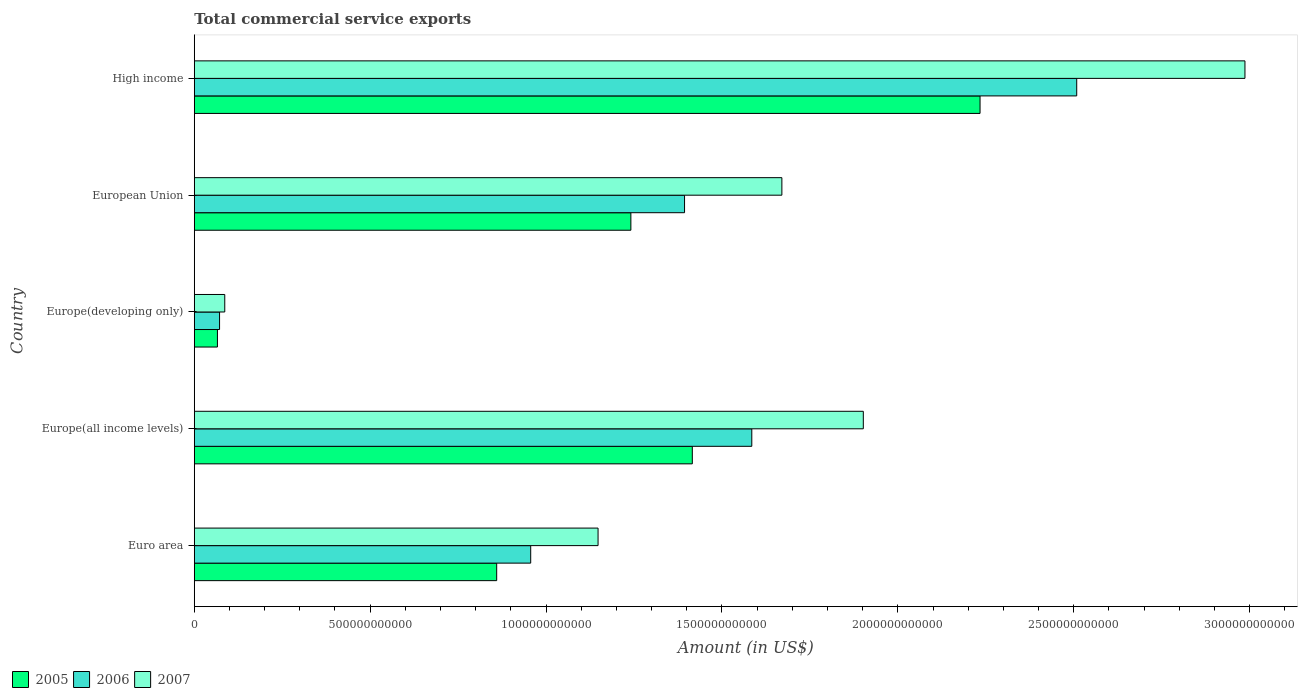How many different coloured bars are there?
Your response must be concise. 3. Are the number of bars per tick equal to the number of legend labels?
Ensure brevity in your answer.  Yes. What is the label of the 5th group of bars from the top?
Provide a short and direct response. Euro area. In how many cases, is the number of bars for a given country not equal to the number of legend labels?
Keep it short and to the point. 0. What is the total commercial service exports in 2005 in Europe(developing only)?
Provide a succinct answer. 6.59e+1. Across all countries, what is the maximum total commercial service exports in 2006?
Provide a succinct answer. 2.51e+12. Across all countries, what is the minimum total commercial service exports in 2006?
Offer a very short reply. 7.19e+1. In which country was the total commercial service exports in 2007 maximum?
Provide a succinct answer. High income. In which country was the total commercial service exports in 2007 minimum?
Keep it short and to the point. Europe(developing only). What is the total total commercial service exports in 2006 in the graph?
Provide a short and direct response. 6.52e+12. What is the difference between the total commercial service exports in 2006 in Europe(developing only) and that in High income?
Your answer should be compact. -2.44e+12. What is the difference between the total commercial service exports in 2007 in Europe(developing only) and the total commercial service exports in 2005 in European Union?
Offer a very short reply. -1.15e+12. What is the average total commercial service exports in 2007 per country?
Provide a short and direct response. 1.56e+12. What is the difference between the total commercial service exports in 2006 and total commercial service exports in 2005 in Euro area?
Give a very brief answer. 9.67e+1. What is the ratio of the total commercial service exports in 2006 in European Union to that in High income?
Offer a terse response. 0.56. Is the total commercial service exports in 2005 in Europe(developing only) less than that in European Union?
Your answer should be very brief. Yes. Is the difference between the total commercial service exports in 2006 in Euro area and European Union greater than the difference between the total commercial service exports in 2005 in Euro area and European Union?
Give a very brief answer. No. What is the difference between the highest and the second highest total commercial service exports in 2007?
Provide a succinct answer. 1.08e+12. What is the difference between the highest and the lowest total commercial service exports in 2006?
Your answer should be very brief. 2.44e+12. In how many countries, is the total commercial service exports in 2005 greater than the average total commercial service exports in 2005 taken over all countries?
Give a very brief answer. 3. What does the 1st bar from the top in High income represents?
Your response must be concise. 2007. What does the 1st bar from the bottom in European Union represents?
Ensure brevity in your answer.  2005. Is it the case that in every country, the sum of the total commercial service exports in 2007 and total commercial service exports in 2006 is greater than the total commercial service exports in 2005?
Your response must be concise. Yes. How many bars are there?
Provide a succinct answer. 15. Are all the bars in the graph horizontal?
Your response must be concise. Yes. How many countries are there in the graph?
Ensure brevity in your answer.  5. What is the difference between two consecutive major ticks on the X-axis?
Provide a succinct answer. 5.00e+11. How are the legend labels stacked?
Offer a terse response. Horizontal. What is the title of the graph?
Ensure brevity in your answer.  Total commercial service exports. What is the label or title of the Y-axis?
Offer a terse response. Country. What is the Amount (in US$) of 2005 in Euro area?
Give a very brief answer. 8.60e+11. What is the Amount (in US$) of 2006 in Euro area?
Your response must be concise. 9.56e+11. What is the Amount (in US$) of 2007 in Euro area?
Offer a terse response. 1.15e+12. What is the Amount (in US$) in 2005 in Europe(all income levels)?
Give a very brief answer. 1.42e+12. What is the Amount (in US$) in 2006 in Europe(all income levels)?
Give a very brief answer. 1.58e+12. What is the Amount (in US$) in 2007 in Europe(all income levels)?
Your answer should be very brief. 1.90e+12. What is the Amount (in US$) of 2005 in Europe(developing only)?
Your answer should be compact. 6.59e+1. What is the Amount (in US$) of 2006 in Europe(developing only)?
Make the answer very short. 7.19e+1. What is the Amount (in US$) of 2007 in Europe(developing only)?
Give a very brief answer. 8.67e+1. What is the Amount (in US$) of 2005 in European Union?
Your answer should be compact. 1.24e+12. What is the Amount (in US$) of 2006 in European Union?
Give a very brief answer. 1.39e+12. What is the Amount (in US$) of 2007 in European Union?
Provide a succinct answer. 1.67e+12. What is the Amount (in US$) in 2005 in High income?
Keep it short and to the point. 2.23e+12. What is the Amount (in US$) in 2006 in High income?
Your response must be concise. 2.51e+12. What is the Amount (in US$) in 2007 in High income?
Offer a terse response. 2.99e+12. Across all countries, what is the maximum Amount (in US$) in 2005?
Make the answer very short. 2.23e+12. Across all countries, what is the maximum Amount (in US$) of 2006?
Offer a very short reply. 2.51e+12. Across all countries, what is the maximum Amount (in US$) in 2007?
Offer a terse response. 2.99e+12. Across all countries, what is the minimum Amount (in US$) in 2005?
Provide a short and direct response. 6.59e+1. Across all countries, what is the minimum Amount (in US$) in 2006?
Give a very brief answer. 7.19e+1. Across all countries, what is the minimum Amount (in US$) in 2007?
Give a very brief answer. 8.67e+1. What is the total Amount (in US$) of 2005 in the graph?
Offer a terse response. 5.82e+12. What is the total Amount (in US$) in 2006 in the graph?
Give a very brief answer. 6.52e+12. What is the total Amount (in US$) of 2007 in the graph?
Make the answer very short. 7.79e+12. What is the difference between the Amount (in US$) in 2005 in Euro area and that in Europe(all income levels)?
Your answer should be compact. -5.56e+11. What is the difference between the Amount (in US$) of 2006 in Euro area and that in Europe(all income levels)?
Make the answer very short. -6.29e+11. What is the difference between the Amount (in US$) of 2007 in Euro area and that in Europe(all income levels)?
Provide a short and direct response. -7.54e+11. What is the difference between the Amount (in US$) in 2005 in Euro area and that in Europe(developing only)?
Ensure brevity in your answer.  7.94e+11. What is the difference between the Amount (in US$) in 2006 in Euro area and that in Europe(developing only)?
Make the answer very short. 8.84e+11. What is the difference between the Amount (in US$) in 2007 in Euro area and that in Europe(developing only)?
Your answer should be very brief. 1.06e+12. What is the difference between the Amount (in US$) of 2005 in Euro area and that in European Union?
Provide a succinct answer. -3.81e+11. What is the difference between the Amount (in US$) in 2006 in Euro area and that in European Union?
Ensure brevity in your answer.  -4.37e+11. What is the difference between the Amount (in US$) of 2007 in Euro area and that in European Union?
Provide a short and direct response. -5.23e+11. What is the difference between the Amount (in US$) in 2005 in Euro area and that in High income?
Ensure brevity in your answer.  -1.37e+12. What is the difference between the Amount (in US$) in 2006 in Euro area and that in High income?
Your answer should be compact. -1.55e+12. What is the difference between the Amount (in US$) in 2007 in Euro area and that in High income?
Your answer should be compact. -1.84e+12. What is the difference between the Amount (in US$) in 2005 in Europe(all income levels) and that in Europe(developing only)?
Make the answer very short. 1.35e+12. What is the difference between the Amount (in US$) of 2006 in Europe(all income levels) and that in Europe(developing only)?
Offer a very short reply. 1.51e+12. What is the difference between the Amount (in US$) of 2007 in Europe(all income levels) and that in Europe(developing only)?
Give a very brief answer. 1.82e+12. What is the difference between the Amount (in US$) in 2005 in Europe(all income levels) and that in European Union?
Provide a succinct answer. 1.75e+11. What is the difference between the Amount (in US$) of 2006 in Europe(all income levels) and that in European Union?
Provide a succinct answer. 1.91e+11. What is the difference between the Amount (in US$) of 2007 in Europe(all income levels) and that in European Union?
Offer a terse response. 2.32e+11. What is the difference between the Amount (in US$) of 2005 in Europe(all income levels) and that in High income?
Provide a short and direct response. -8.18e+11. What is the difference between the Amount (in US$) in 2006 in Europe(all income levels) and that in High income?
Your answer should be very brief. -9.24e+11. What is the difference between the Amount (in US$) in 2007 in Europe(all income levels) and that in High income?
Provide a short and direct response. -1.08e+12. What is the difference between the Amount (in US$) in 2005 in Europe(developing only) and that in European Union?
Your response must be concise. -1.18e+12. What is the difference between the Amount (in US$) in 2006 in Europe(developing only) and that in European Union?
Your answer should be compact. -1.32e+12. What is the difference between the Amount (in US$) in 2007 in Europe(developing only) and that in European Union?
Make the answer very short. -1.58e+12. What is the difference between the Amount (in US$) in 2005 in Europe(developing only) and that in High income?
Your answer should be very brief. -2.17e+12. What is the difference between the Amount (in US$) in 2006 in Europe(developing only) and that in High income?
Offer a very short reply. -2.44e+12. What is the difference between the Amount (in US$) in 2007 in Europe(developing only) and that in High income?
Provide a succinct answer. -2.90e+12. What is the difference between the Amount (in US$) in 2005 in European Union and that in High income?
Offer a very short reply. -9.93e+11. What is the difference between the Amount (in US$) of 2006 in European Union and that in High income?
Offer a very short reply. -1.11e+12. What is the difference between the Amount (in US$) in 2007 in European Union and that in High income?
Your answer should be compact. -1.32e+12. What is the difference between the Amount (in US$) of 2005 in Euro area and the Amount (in US$) of 2006 in Europe(all income levels)?
Your answer should be very brief. -7.25e+11. What is the difference between the Amount (in US$) of 2005 in Euro area and the Amount (in US$) of 2007 in Europe(all income levels)?
Your response must be concise. -1.04e+12. What is the difference between the Amount (in US$) in 2006 in Euro area and the Amount (in US$) in 2007 in Europe(all income levels)?
Keep it short and to the point. -9.46e+11. What is the difference between the Amount (in US$) of 2005 in Euro area and the Amount (in US$) of 2006 in Europe(developing only)?
Provide a short and direct response. 7.88e+11. What is the difference between the Amount (in US$) in 2005 in Euro area and the Amount (in US$) in 2007 in Europe(developing only)?
Your answer should be compact. 7.73e+11. What is the difference between the Amount (in US$) in 2006 in Euro area and the Amount (in US$) in 2007 in Europe(developing only)?
Ensure brevity in your answer.  8.70e+11. What is the difference between the Amount (in US$) of 2005 in Euro area and the Amount (in US$) of 2006 in European Union?
Provide a succinct answer. -5.34e+11. What is the difference between the Amount (in US$) of 2005 in Euro area and the Amount (in US$) of 2007 in European Union?
Provide a succinct answer. -8.11e+11. What is the difference between the Amount (in US$) in 2006 in Euro area and the Amount (in US$) in 2007 in European Union?
Provide a short and direct response. -7.14e+11. What is the difference between the Amount (in US$) of 2005 in Euro area and the Amount (in US$) of 2006 in High income?
Give a very brief answer. -1.65e+12. What is the difference between the Amount (in US$) of 2005 in Euro area and the Amount (in US$) of 2007 in High income?
Keep it short and to the point. -2.13e+12. What is the difference between the Amount (in US$) of 2006 in Euro area and the Amount (in US$) of 2007 in High income?
Give a very brief answer. -2.03e+12. What is the difference between the Amount (in US$) of 2005 in Europe(all income levels) and the Amount (in US$) of 2006 in Europe(developing only)?
Offer a very short reply. 1.34e+12. What is the difference between the Amount (in US$) in 2005 in Europe(all income levels) and the Amount (in US$) in 2007 in Europe(developing only)?
Your answer should be very brief. 1.33e+12. What is the difference between the Amount (in US$) of 2006 in Europe(all income levels) and the Amount (in US$) of 2007 in Europe(developing only)?
Keep it short and to the point. 1.50e+12. What is the difference between the Amount (in US$) of 2005 in Europe(all income levels) and the Amount (in US$) of 2006 in European Union?
Give a very brief answer. 2.21e+1. What is the difference between the Amount (in US$) in 2005 in Europe(all income levels) and the Amount (in US$) in 2007 in European Union?
Your response must be concise. -2.55e+11. What is the difference between the Amount (in US$) in 2006 in Europe(all income levels) and the Amount (in US$) in 2007 in European Union?
Make the answer very short. -8.55e+1. What is the difference between the Amount (in US$) in 2005 in Europe(all income levels) and the Amount (in US$) in 2006 in High income?
Keep it short and to the point. -1.09e+12. What is the difference between the Amount (in US$) of 2005 in Europe(all income levels) and the Amount (in US$) of 2007 in High income?
Ensure brevity in your answer.  -1.57e+12. What is the difference between the Amount (in US$) in 2006 in Europe(all income levels) and the Amount (in US$) in 2007 in High income?
Make the answer very short. -1.40e+12. What is the difference between the Amount (in US$) in 2005 in Europe(developing only) and the Amount (in US$) in 2006 in European Union?
Your response must be concise. -1.33e+12. What is the difference between the Amount (in US$) in 2005 in Europe(developing only) and the Amount (in US$) in 2007 in European Union?
Offer a terse response. -1.60e+12. What is the difference between the Amount (in US$) of 2006 in Europe(developing only) and the Amount (in US$) of 2007 in European Union?
Offer a very short reply. -1.60e+12. What is the difference between the Amount (in US$) of 2005 in Europe(developing only) and the Amount (in US$) of 2006 in High income?
Your answer should be compact. -2.44e+12. What is the difference between the Amount (in US$) in 2005 in Europe(developing only) and the Amount (in US$) in 2007 in High income?
Your answer should be compact. -2.92e+12. What is the difference between the Amount (in US$) in 2006 in Europe(developing only) and the Amount (in US$) in 2007 in High income?
Offer a terse response. -2.91e+12. What is the difference between the Amount (in US$) of 2005 in European Union and the Amount (in US$) of 2006 in High income?
Ensure brevity in your answer.  -1.27e+12. What is the difference between the Amount (in US$) of 2005 in European Union and the Amount (in US$) of 2007 in High income?
Provide a short and direct response. -1.75e+12. What is the difference between the Amount (in US$) in 2006 in European Union and the Amount (in US$) in 2007 in High income?
Give a very brief answer. -1.59e+12. What is the average Amount (in US$) of 2005 per country?
Offer a terse response. 1.16e+12. What is the average Amount (in US$) in 2006 per country?
Your response must be concise. 1.30e+12. What is the average Amount (in US$) in 2007 per country?
Give a very brief answer. 1.56e+12. What is the difference between the Amount (in US$) of 2005 and Amount (in US$) of 2006 in Euro area?
Your answer should be compact. -9.67e+1. What is the difference between the Amount (in US$) of 2005 and Amount (in US$) of 2007 in Euro area?
Ensure brevity in your answer.  -2.88e+11. What is the difference between the Amount (in US$) of 2006 and Amount (in US$) of 2007 in Euro area?
Your answer should be very brief. -1.91e+11. What is the difference between the Amount (in US$) of 2005 and Amount (in US$) of 2006 in Europe(all income levels)?
Offer a very short reply. -1.69e+11. What is the difference between the Amount (in US$) in 2005 and Amount (in US$) in 2007 in Europe(all income levels)?
Provide a short and direct response. -4.86e+11. What is the difference between the Amount (in US$) of 2006 and Amount (in US$) of 2007 in Europe(all income levels)?
Give a very brief answer. -3.17e+11. What is the difference between the Amount (in US$) in 2005 and Amount (in US$) in 2006 in Europe(developing only)?
Provide a succinct answer. -6.08e+09. What is the difference between the Amount (in US$) in 2005 and Amount (in US$) in 2007 in Europe(developing only)?
Your answer should be compact. -2.09e+1. What is the difference between the Amount (in US$) of 2006 and Amount (in US$) of 2007 in Europe(developing only)?
Your answer should be compact. -1.48e+1. What is the difference between the Amount (in US$) in 2005 and Amount (in US$) in 2006 in European Union?
Provide a succinct answer. -1.53e+11. What is the difference between the Amount (in US$) in 2005 and Amount (in US$) in 2007 in European Union?
Provide a short and direct response. -4.29e+11. What is the difference between the Amount (in US$) in 2006 and Amount (in US$) in 2007 in European Union?
Your answer should be very brief. -2.77e+11. What is the difference between the Amount (in US$) in 2005 and Amount (in US$) in 2006 in High income?
Give a very brief answer. -2.75e+11. What is the difference between the Amount (in US$) of 2005 and Amount (in US$) of 2007 in High income?
Make the answer very short. -7.53e+11. What is the difference between the Amount (in US$) in 2006 and Amount (in US$) in 2007 in High income?
Your answer should be compact. -4.78e+11. What is the ratio of the Amount (in US$) in 2005 in Euro area to that in Europe(all income levels)?
Your response must be concise. 0.61. What is the ratio of the Amount (in US$) of 2006 in Euro area to that in Europe(all income levels)?
Make the answer very short. 0.6. What is the ratio of the Amount (in US$) in 2007 in Euro area to that in Europe(all income levels)?
Provide a succinct answer. 0.6. What is the ratio of the Amount (in US$) in 2005 in Euro area to that in Europe(developing only)?
Offer a very short reply. 13.06. What is the ratio of the Amount (in US$) of 2006 in Euro area to that in Europe(developing only)?
Ensure brevity in your answer.  13.3. What is the ratio of the Amount (in US$) in 2007 in Euro area to that in Europe(developing only)?
Your answer should be very brief. 13.24. What is the ratio of the Amount (in US$) in 2005 in Euro area to that in European Union?
Your answer should be very brief. 0.69. What is the ratio of the Amount (in US$) in 2006 in Euro area to that in European Union?
Offer a terse response. 0.69. What is the ratio of the Amount (in US$) in 2007 in Euro area to that in European Union?
Keep it short and to the point. 0.69. What is the ratio of the Amount (in US$) of 2005 in Euro area to that in High income?
Offer a very short reply. 0.38. What is the ratio of the Amount (in US$) of 2006 in Euro area to that in High income?
Ensure brevity in your answer.  0.38. What is the ratio of the Amount (in US$) of 2007 in Euro area to that in High income?
Keep it short and to the point. 0.38. What is the ratio of the Amount (in US$) of 2005 in Europe(all income levels) to that in Europe(developing only)?
Keep it short and to the point. 21.5. What is the ratio of the Amount (in US$) in 2006 in Europe(all income levels) to that in Europe(developing only)?
Your answer should be compact. 22.03. What is the ratio of the Amount (in US$) in 2007 in Europe(all income levels) to that in Europe(developing only)?
Your answer should be very brief. 21.93. What is the ratio of the Amount (in US$) in 2005 in Europe(all income levels) to that in European Union?
Offer a terse response. 1.14. What is the ratio of the Amount (in US$) of 2006 in Europe(all income levels) to that in European Union?
Ensure brevity in your answer.  1.14. What is the ratio of the Amount (in US$) of 2007 in Europe(all income levels) to that in European Union?
Provide a short and direct response. 1.14. What is the ratio of the Amount (in US$) of 2005 in Europe(all income levels) to that in High income?
Your answer should be very brief. 0.63. What is the ratio of the Amount (in US$) in 2006 in Europe(all income levels) to that in High income?
Your answer should be very brief. 0.63. What is the ratio of the Amount (in US$) in 2007 in Europe(all income levels) to that in High income?
Ensure brevity in your answer.  0.64. What is the ratio of the Amount (in US$) of 2005 in Europe(developing only) to that in European Union?
Keep it short and to the point. 0.05. What is the ratio of the Amount (in US$) in 2006 in Europe(developing only) to that in European Union?
Keep it short and to the point. 0.05. What is the ratio of the Amount (in US$) of 2007 in Europe(developing only) to that in European Union?
Keep it short and to the point. 0.05. What is the ratio of the Amount (in US$) of 2005 in Europe(developing only) to that in High income?
Provide a short and direct response. 0.03. What is the ratio of the Amount (in US$) in 2006 in Europe(developing only) to that in High income?
Your answer should be compact. 0.03. What is the ratio of the Amount (in US$) of 2007 in Europe(developing only) to that in High income?
Ensure brevity in your answer.  0.03. What is the ratio of the Amount (in US$) in 2005 in European Union to that in High income?
Your answer should be compact. 0.56. What is the ratio of the Amount (in US$) in 2006 in European Union to that in High income?
Make the answer very short. 0.56. What is the ratio of the Amount (in US$) in 2007 in European Union to that in High income?
Your answer should be compact. 0.56. What is the difference between the highest and the second highest Amount (in US$) in 2005?
Ensure brevity in your answer.  8.18e+11. What is the difference between the highest and the second highest Amount (in US$) of 2006?
Your response must be concise. 9.24e+11. What is the difference between the highest and the second highest Amount (in US$) in 2007?
Your answer should be very brief. 1.08e+12. What is the difference between the highest and the lowest Amount (in US$) in 2005?
Your response must be concise. 2.17e+12. What is the difference between the highest and the lowest Amount (in US$) of 2006?
Your answer should be compact. 2.44e+12. What is the difference between the highest and the lowest Amount (in US$) of 2007?
Your answer should be compact. 2.90e+12. 